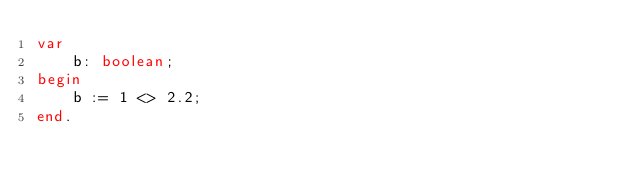Convert code to text. <code><loc_0><loc_0><loc_500><loc_500><_Pascal_>var
    b: boolean;
begin
    b := 1 <> 2.2;
end.</code> 